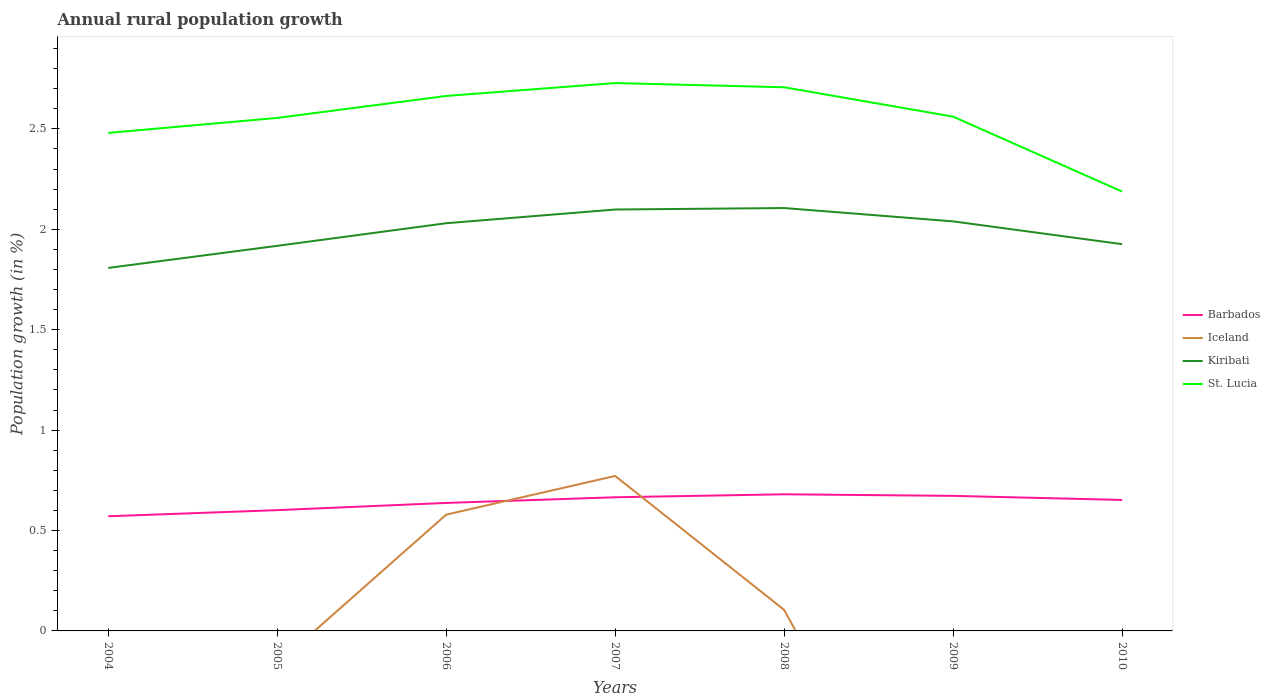How many different coloured lines are there?
Keep it short and to the point. 4. Is the number of lines equal to the number of legend labels?
Make the answer very short. No. Across all years, what is the maximum percentage of rural population growth in St. Lucia?
Provide a short and direct response. 2.19. What is the total percentage of rural population growth in St. Lucia in the graph?
Provide a succinct answer. -0.08. What is the difference between the highest and the second highest percentage of rural population growth in Barbados?
Give a very brief answer. 0.11. Does the graph contain any zero values?
Give a very brief answer. Yes. How are the legend labels stacked?
Your response must be concise. Vertical. What is the title of the graph?
Provide a short and direct response. Annual rural population growth. What is the label or title of the Y-axis?
Offer a very short reply. Population growth (in %). What is the Population growth (in %) in Barbados in 2004?
Make the answer very short. 0.57. What is the Population growth (in %) of Iceland in 2004?
Offer a very short reply. 0. What is the Population growth (in %) in Kiribati in 2004?
Give a very brief answer. 1.81. What is the Population growth (in %) of St. Lucia in 2004?
Your answer should be compact. 2.48. What is the Population growth (in %) of Barbados in 2005?
Make the answer very short. 0.6. What is the Population growth (in %) in Kiribati in 2005?
Your answer should be very brief. 1.92. What is the Population growth (in %) of St. Lucia in 2005?
Offer a terse response. 2.55. What is the Population growth (in %) of Barbados in 2006?
Provide a short and direct response. 0.64. What is the Population growth (in %) in Iceland in 2006?
Your answer should be very brief. 0.58. What is the Population growth (in %) of Kiribati in 2006?
Your response must be concise. 2.03. What is the Population growth (in %) of St. Lucia in 2006?
Your response must be concise. 2.66. What is the Population growth (in %) in Barbados in 2007?
Ensure brevity in your answer.  0.67. What is the Population growth (in %) in Iceland in 2007?
Offer a very short reply. 0.77. What is the Population growth (in %) of Kiribati in 2007?
Offer a terse response. 2.1. What is the Population growth (in %) of St. Lucia in 2007?
Make the answer very short. 2.73. What is the Population growth (in %) of Barbados in 2008?
Ensure brevity in your answer.  0.68. What is the Population growth (in %) in Iceland in 2008?
Your answer should be compact. 0.1. What is the Population growth (in %) in Kiribati in 2008?
Your response must be concise. 2.11. What is the Population growth (in %) of St. Lucia in 2008?
Your answer should be very brief. 2.71. What is the Population growth (in %) in Barbados in 2009?
Make the answer very short. 0.67. What is the Population growth (in %) of Kiribati in 2009?
Your response must be concise. 2.04. What is the Population growth (in %) in St. Lucia in 2009?
Make the answer very short. 2.56. What is the Population growth (in %) in Barbados in 2010?
Give a very brief answer. 0.65. What is the Population growth (in %) in Kiribati in 2010?
Make the answer very short. 1.93. What is the Population growth (in %) in St. Lucia in 2010?
Keep it short and to the point. 2.19. Across all years, what is the maximum Population growth (in %) of Barbados?
Your answer should be very brief. 0.68. Across all years, what is the maximum Population growth (in %) of Iceland?
Provide a succinct answer. 0.77. Across all years, what is the maximum Population growth (in %) in Kiribati?
Your answer should be compact. 2.11. Across all years, what is the maximum Population growth (in %) of St. Lucia?
Make the answer very short. 2.73. Across all years, what is the minimum Population growth (in %) of Barbados?
Your response must be concise. 0.57. Across all years, what is the minimum Population growth (in %) of Kiribati?
Provide a succinct answer. 1.81. Across all years, what is the minimum Population growth (in %) of St. Lucia?
Your answer should be very brief. 2.19. What is the total Population growth (in %) in Barbados in the graph?
Provide a short and direct response. 4.48. What is the total Population growth (in %) of Iceland in the graph?
Keep it short and to the point. 1.46. What is the total Population growth (in %) of Kiribati in the graph?
Provide a succinct answer. 13.93. What is the total Population growth (in %) in St. Lucia in the graph?
Offer a terse response. 17.88. What is the difference between the Population growth (in %) in Barbados in 2004 and that in 2005?
Provide a succinct answer. -0.03. What is the difference between the Population growth (in %) of Kiribati in 2004 and that in 2005?
Offer a terse response. -0.11. What is the difference between the Population growth (in %) of St. Lucia in 2004 and that in 2005?
Provide a short and direct response. -0.07. What is the difference between the Population growth (in %) of Barbados in 2004 and that in 2006?
Offer a very short reply. -0.07. What is the difference between the Population growth (in %) in Kiribati in 2004 and that in 2006?
Offer a very short reply. -0.22. What is the difference between the Population growth (in %) in St. Lucia in 2004 and that in 2006?
Keep it short and to the point. -0.18. What is the difference between the Population growth (in %) of Barbados in 2004 and that in 2007?
Your response must be concise. -0.09. What is the difference between the Population growth (in %) in Kiribati in 2004 and that in 2007?
Make the answer very short. -0.29. What is the difference between the Population growth (in %) of St. Lucia in 2004 and that in 2007?
Ensure brevity in your answer.  -0.25. What is the difference between the Population growth (in %) of Barbados in 2004 and that in 2008?
Keep it short and to the point. -0.11. What is the difference between the Population growth (in %) in Kiribati in 2004 and that in 2008?
Give a very brief answer. -0.3. What is the difference between the Population growth (in %) of St. Lucia in 2004 and that in 2008?
Offer a terse response. -0.23. What is the difference between the Population growth (in %) in Barbados in 2004 and that in 2009?
Keep it short and to the point. -0.1. What is the difference between the Population growth (in %) in Kiribati in 2004 and that in 2009?
Your response must be concise. -0.23. What is the difference between the Population growth (in %) in St. Lucia in 2004 and that in 2009?
Offer a very short reply. -0.08. What is the difference between the Population growth (in %) of Barbados in 2004 and that in 2010?
Provide a short and direct response. -0.08. What is the difference between the Population growth (in %) in Kiribati in 2004 and that in 2010?
Your answer should be very brief. -0.12. What is the difference between the Population growth (in %) of St. Lucia in 2004 and that in 2010?
Make the answer very short. 0.29. What is the difference between the Population growth (in %) in Barbados in 2005 and that in 2006?
Provide a succinct answer. -0.04. What is the difference between the Population growth (in %) in Kiribati in 2005 and that in 2006?
Offer a terse response. -0.11. What is the difference between the Population growth (in %) in St. Lucia in 2005 and that in 2006?
Ensure brevity in your answer.  -0.11. What is the difference between the Population growth (in %) of Barbados in 2005 and that in 2007?
Give a very brief answer. -0.06. What is the difference between the Population growth (in %) in Kiribati in 2005 and that in 2007?
Make the answer very short. -0.18. What is the difference between the Population growth (in %) of St. Lucia in 2005 and that in 2007?
Your answer should be very brief. -0.17. What is the difference between the Population growth (in %) of Barbados in 2005 and that in 2008?
Keep it short and to the point. -0.08. What is the difference between the Population growth (in %) of Kiribati in 2005 and that in 2008?
Offer a terse response. -0.19. What is the difference between the Population growth (in %) in St. Lucia in 2005 and that in 2008?
Provide a short and direct response. -0.15. What is the difference between the Population growth (in %) in Barbados in 2005 and that in 2009?
Your answer should be compact. -0.07. What is the difference between the Population growth (in %) in Kiribati in 2005 and that in 2009?
Provide a succinct answer. -0.12. What is the difference between the Population growth (in %) of St. Lucia in 2005 and that in 2009?
Your response must be concise. -0.01. What is the difference between the Population growth (in %) in Barbados in 2005 and that in 2010?
Your answer should be very brief. -0.05. What is the difference between the Population growth (in %) in Kiribati in 2005 and that in 2010?
Your answer should be very brief. -0.01. What is the difference between the Population growth (in %) in St. Lucia in 2005 and that in 2010?
Offer a terse response. 0.37. What is the difference between the Population growth (in %) of Barbados in 2006 and that in 2007?
Your answer should be very brief. -0.03. What is the difference between the Population growth (in %) of Iceland in 2006 and that in 2007?
Offer a very short reply. -0.19. What is the difference between the Population growth (in %) in Kiribati in 2006 and that in 2007?
Provide a short and direct response. -0.07. What is the difference between the Population growth (in %) in St. Lucia in 2006 and that in 2007?
Provide a short and direct response. -0.06. What is the difference between the Population growth (in %) in Barbados in 2006 and that in 2008?
Your response must be concise. -0.04. What is the difference between the Population growth (in %) in Iceland in 2006 and that in 2008?
Offer a very short reply. 0.47. What is the difference between the Population growth (in %) of Kiribati in 2006 and that in 2008?
Your response must be concise. -0.08. What is the difference between the Population growth (in %) in St. Lucia in 2006 and that in 2008?
Your response must be concise. -0.04. What is the difference between the Population growth (in %) in Barbados in 2006 and that in 2009?
Provide a succinct answer. -0.04. What is the difference between the Population growth (in %) in Kiribati in 2006 and that in 2009?
Provide a succinct answer. -0.01. What is the difference between the Population growth (in %) of St. Lucia in 2006 and that in 2009?
Offer a terse response. 0.1. What is the difference between the Population growth (in %) in Barbados in 2006 and that in 2010?
Ensure brevity in your answer.  -0.01. What is the difference between the Population growth (in %) of Kiribati in 2006 and that in 2010?
Your response must be concise. 0.1. What is the difference between the Population growth (in %) in St. Lucia in 2006 and that in 2010?
Make the answer very short. 0.48. What is the difference between the Population growth (in %) in Barbados in 2007 and that in 2008?
Make the answer very short. -0.01. What is the difference between the Population growth (in %) of Kiribati in 2007 and that in 2008?
Offer a very short reply. -0.01. What is the difference between the Population growth (in %) in St. Lucia in 2007 and that in 2008?
Offer a very short reply. 0.02. What is the difference between the Population growth (in %) of Barbados in 2007 and that in 2009?
Offer a terse response. -0.01. What is the difference between the Population growth (in %) of Kiribati in 2007 and that in 2009?
Your answer should be compact. 0.06. What is the difference between the Population growth (in %) in St. Lucia in 2007 and that in 2009?
Make the answer very short. 0.17. What is the difference between the Population growth (in %) of Barbados in 2007 and that in 2010?
Provide a succinct answer. 0.01. What is the difference between the Population growth (in %) of Kiribati in 2007 and that in 2010?
Your answer should be compact. 0.17. What is the difference between the Population growth (in %) in St. Lucia in 2007 and that in 2010?
Provide a succinct answer. 0.54. What is the difference between the Population growth (in %) of Barbados in 2008 and that in 2009?
Your answer should be compact. 0.01. What is the difference between the Population growth (in %) of Kiribati in 2008 and that in 2009?
Your answer should be very brief. 0.07. What is the difference between the Population growth (in %) of St. Lucia in 2008 and that in 2009?
Give a very brief answer. 0.15. What is the difference between the Population growth (in %) of Barbados in 2008 and that in 2010?
Offer a very short reply. 0.03. What is the difference between the Population growth (in %) in Kiribati in 2008 and that in 2010?
Offer a terse response. 0.18. What is the difference between the Population growth (in %) of St. Lucia in 2008 and that in 2010?
Your response must be concise. 0.52. What is the difference between the Population growth (in %) of Barbados in 2009 and that in 2010?
Make the answer very short. 0.02. What is the difference between the Population growth (in %) of Kiribati in 2009 and that in 2010?
Ensure brevity in your answer.  0.11. What is the difference between the Population growth (in %) in St. Lucia in 2009 and that in 2010?
Your answer should be very brief. 0.37. What is the difference between the Population growth (in %) of Barbados in 2004 and the Population growth (in %) of Kiribati in 2005?
Your answer should be very brief. -1.35. What is the difference between the Population growth (in %) of Barbados in 2004 and the Population growth (in %) of St. Lucia in 2005?
Your answer should be very brief. -1.98. What is the difference between the Population growth (in %) in Kiribati in 2004 and the Population growth (in %) in St. Lucia in 2005?
Give a very brief answer. -0.75. What is the difference between the Population growth (in %) of Barbados in 2004 and the Population growth (in %) of Iceland in 2006?
Give a very brief answer. -0.01. What is the difference between the Population growth (in %) of Barbados in 2004 and the Population growth (in %) of Kiribati in 2006?
Your answer should be very brief. -1.46. What is the difference between the Population growth (in %) in Barbados in 2004 and the Population growth (in %) in St. Lucia in 2006?
Your answer should be compact. -2.09. What is the difference between the Population growth (in %) in Kiribati in 2004 and the Population growth (in %) in St. Lucia in 2006?
Make the answer very short. -0.86. What is the difference between the Population growth (in %) in Barbados in 2004 and the Population growth (in %) in Iceland in 2007?
Offer a very short reply. -0.2. What is the difference between the Population growth (in %) in Barbados in 2004 and the Population growth (in %) in Kiribati in 2007?
Offer a very short reply. -1.53. What is the difference between the Population growth (in %) in Barbados in 2004 and the Population growth (in %) in St. Lucia in 2007?
Give a very brief answer. -2.16. What is the difference between the Population growth (in %) in Kiribati in 2004 and the Population growth (in %) in St. Lucia in 2007?
Offer a very short reply. -0.92. What is the difference between the Population growth (in %) of Barbados in 2004 and the Population growth (in %) of Iceland in 2008?
Ensure brevity in your answer.  0.47. What is the difference between the Population growth (in %) in Barbados in 2004 and the Population growth (in %) in Kiribati in 2008?
Offer a terse response. -1.53. What is the difference between the Population growth (in %) of Barbados in 2004 and the Population growth (in %) of St. Lucia in 2008?
Keep it short and to the point. -2.14. What is the difference between the Population growth (in %) of Kiribati in 2004 and the Population growth (in %) of St. Lucia in 2008?
Offer a very short reply. -0.9. What is the difference between the Population growth (in %) in Barbados in 2004 and the Population growth (in %) in Kiribati in 2009?
Your answer should be compact. -1.47. What is the difference between the Population growth (in %) in Barbados in 2004 and the Population growth (in %) in St. Lucia in 2009?
Offer a very short reply. -1.99. What is the difference between the Population growth (in %) of Kiribati in 2004 and the Population growth (in %) of St. Lucia in 2009?
Provide a succinct answer. -0.75. What is the difference between the Population growth (in %) in Barbados in 2004 and the Population growth (in %) in Kiribati in 2010?
Make the answer very short. -1.35. What is the difference between the Population growth (in %) of Barbados in 2004 and the Population growth (in %) of St. Lucia in 2010?
Provide a succinct answer. -1.62. What is the difference between the Population growth (in %) in Kiribati in 2004 and the Population growth (in %) in St. Lucia in 2010?
Provide a succinct answer. -0.38. What is the difference between the Population growth (in %) of Barbados in 2005 and the Population growth (in %) of Iceland in 2006?
Make the answer very short. 0.02. What is the difference between the Population growth (in %) of Barbados in 2005 and the Population growth (in %) of Kiribati in 2006?
Provide a succinct answer. -1.43. What is the difference between the Population growth (in %) of Barbados in 2005 and the Population growth (in %) of St. Lucia in 2006?
Give a very brief answer. -2.06. What is the difference between the Population growth (in %) of Kiribati in 2005 and the Population growth (in %) of St. Lucia in 2006?
Offer a terse response. -0.75. What is the difference between the Population growth (in %) of Barbados in 2005 and the Population growth (in %) of Iceland in 2007?
Provide a succinct answer. -0.17. What is the difference between the Population growth (in %) of Barbados in 2005 and the Population growth (in %) of Kiribati in 2007?
Offer a very short reply. -1.5. What is the difference between the Population growth (in %) in Barbados in 2005 and the Population growth (in %) in St. Lucia in 2007?
Ensure brevity in your answer.  -2.13. What is the difference between the Population growth (in %) of Kiribati in 2005 and the Population growth (in %) of St. Lucia in 2007?
Offer a very short reply. -0.81. What is the difference between the Population growth (in %) of Barbados in 2005 and the Population growth (in %) of Iceland in 2008?
Make the answer very short. 0.5. What is the difference between the Population growth (in %) of Barbados in 2005 and the Population growth (in %) of Kiribati in 2008?
Offer a very short reply. -1.5. What is the difference between the Population growth (in %) in Barbados in 2005 and the Population growth (in %) in St. Lucia in 2008?
Make the answer very short. -2.11. What is the difference between the Population growth (in %) in Kiribati in 2005 and the Population growth (in %) in St. Lucia in 2008?
Offer a terse response. -0.79. What is the difference between the Population growth (in %) of Barbados in 2005 and the Population growth (in %) of Kiribati in 2009?
Offer a terse response. -1.44. What is the difference between the Population growth (in %) of Barbados in 2005 and the Population growth (in %) of St. Lucia in 2009?
Provide a succinct answer. -1.96. What is the difference between the Population growth (in %) of Kiribati in 2005 and the Population growth (in %) of St. Lucia in 2009?
Your answer should be compact. -0.64. What is the difference between the Population growth (in %) of Barbados in 2005 and the Population growth (in %) of Kiribati in 2010?
Your answer should be compact. -1.32. What is the difference between the Population growth (in %) in Barbados in 2005 and the Population growth (in %) in St. Lucia in 2010?
Offer a terse response. -1.59. What is the difference between the Population growth (in %) in Kiribati in 2005 and the Population growth (in %) in St. Lucia in 2010?
Your answer should be very brief. -0.27. What is the difference between the Population growth (in %) in Barbados in 2006 and the Population growth (in %) in Iceland in 2007?
Provide a succinct answer. -0.13. What is the difference between the Population growth (in %) of Barbados in 2006 and the Population growth (in %) of Kiribati in 2007?
Provide a succinct answer. -1.46. What is the difference between the Population growth (in %) of Barbados in 2006 and the Population growth (in %) of St. Lucia in 2007?
Keep it short and to the point. -2.09. What is the difference between the Population growth (in %) of Iceland in 2006 and the Population growth (in %) of Kiribati in 2007?
Keep it short and to the point. -1.52. What is the difference between the Population growth (in %) of Iceland in 2006 and the Population growth (in %) of St. Lucia in 2007?
Keep it short and to the point. -2.15. What is the difference between the Population growth (in %) of Kiribati in 2006 and the Population growth (in %) of St. Lucia in 2007?
Your answer should be compact. -0.7. What is the difference between the Population growth (in %) of Barbados in 2006 and the Population growth (in %) of Iceland in 2008?
Ensure brevity in your answer.  0.53. What is the difference between the Population growth (in %) of Barbados in 2006 and the Population growth (in %) of Kiribati in 2008?
Give a very brief answer. -1.47. What is the difference between the Population growth (in %) in Barbados in 2006 and the Population growth (in %) in St. Lucia in 2008?
Your answer should be compact. -2.07. What is the difference between the Population growth (in %) in Iceland in 2006 and the Population growth (in %) in Kiribati in 2008?
Keep it short and to the point. -1.53. What is the difference between the Population growth (in %) in Iceland in 2006 and the Population growth (in %) in St. Lucia in 2008?
Provide a succinct answer. -2.13. What is the difference between the Population growth (in %) of Kiribati in 2006 and the Population growth (in %) of St. Lucia in 2008?
Keep it short and to the point. -0.68. What is the difference between the Population growth (in %) of Barbados in 2006 and the Population growth (in %) of Kiribati in 2009?
Ensure brevity in your answer.  -1.4. What is the difference between the Population growth (in %) in Barbados in 2006 and the Population growth (in %) in St. Lucia in 2009?
Offer a very short reply. -1.92. What is the difference between the Population growth (in %) of Iceland in 2006 and the Population growth (in %) of Kiribati in 2009?
Provide a succinct answer. -1.46. What is the difference between the Population growth (in %) in Iceland in 2006 and the Population growth (in %) in St. Lucia in 2009?
Offer a very short reply. -1.98. What is the difference between the Population growth (in %) in Kiribati in 2006 and the Population growth (in %) in St. Lucia in 2009?
Your response must be concise. -0.53. What is the difference between the Population growth (in %) in Barbados in 2006 and the Population growth (in %) in Kiribati in 2010?
Keep it short and to the point. -1.29. What is the difference between the Population growth (in %) in Barbados in 2006 and the Population growth (in %) in St. Lucia in 2010?
Offer a very short reply. -1.55. What is the difference between the Population growth (in %) in Iceland in 2006 and the Population growth (in %) in Kiribati in 2010?
Your response must be concise. -1.35. What is the difference between the Population growth (in %) in Iceland in 2006 and the Population growth (in %) in St. Lucia in 2010?
Provide a succinct answer. -1.61. What is the difference between the Population growth (in %) in Kiribati in 2006 and the Population growth (in %) in St. Lucia in 2010?
Provide a succinct answer. -0.16. What is the difference between the Population growth (in %) in Barbados in 2007 and the Population growth (in %) in Iceland in 2008?
Your answer should be compact. 0.56. What is the difference between the Population growth (in %) in Barbados in 2007 and the Population growth (in %) in Kiribati in 2008?
Make the answer very short. -1.44. What is the difference between the Population growth (in %) of Barbados in 2007 and the Population growth (in %) of St. Lucia in 2008?
Your answer should be compact. -2.04. What is the difference between the Population growth (in %) in Iceland in 2007 and the Population growth (in %) in Kiribati in 2008?
Keep it short and to the point. -1.33. What is the difference between the Population growth (in %) in Iceland in 2007 and the Population growth (in %) in St. Lucia in 2008?
Your response must be concise. -1.94. What is the difference between the Population growth (in %) of Kiribati in 2007 and the Population growth (in %) of St. Lucia in 2008?
Provide a succinct answer. -0.61. What is the difference between the Population growth (in %) of Barbados in 2007 and the Population growth (in %) of Kiribati in 2009?
Your answer should be very brief. -1.37. What is the difference between the Population growth (in %) in Barbados in 2007 and the Population growth (in %) in St. Lucia in 2009?
Your response must be concise. -1.9. What is the difference between the Population growth (in %) of Iceland in 2007 and the Population growth (in %) of Kiribati in 2009?
Give a very brief answer. -1.27. What is the difference between the Population growth (in %) of Iceland in 2007 and the Population growth (in %) of St. Lucia in 2009?
Ensure brevity in your answer.  -1.79. What is the difference between the Population growth (in %) of Kiribati in 2007 and the Population growth (in %) of St. Lucia in 2009?
Keep it short and to the point. -0.46. What is the difference between the Population growth (in %) in Barbados in 2007 and the Population growth (in %) in Kiribati in 2010?
Offer a terse response. -1.26. What is the difference between the Population growth (in %) of Barbados in 2007 and the Population growth (in %) of St. Lucia in 2010?
Ensure brevity in your answer.  -1.52. What is the difference between the Population growth (in %) in Iceland in 2007 and the Population growth (in %) in Kiribati in 2010?
Offer a very short reply. -1.15. What is the difference between the Population growth (in %) in Iceland in 2007 and the Population growth (in %) in St. Lucia in 2010?
Ensure brevity in your answer.  -1.42. What is the difference between the Population growth (in %) of Kiribati in 2007 and the Population growth (in %) of St. Lucia in 2010?
Offer a very short reply. -0.09. What is the difference between the Population growth (in %) in Barbados in 2008 and the Population growth (in %) in Kiribati in 2009?
Ensure brevity in your answer.  -1.36. What is the difference between the Population growth (in %) of Barbados in 2008 and the Population growth (in %) of St. Lucia in 2009?
Your response must be concise. -1.88. What is the difference between the Population growth (in %) in Iceland in 2008 and the Population growth (in %) in Kiribati in 2009?
Offer a very short reply. -1.93. What is the difference between the Population growth (in %) in Iceland in 2008 and the Population growth (in %) in St. Lucia in 2009?
Offer a very short reply. -2.46. What is the difference between the Population growth (in %) in Kiribati in 2008 and the Population growth (in %) in St. Lucia in 2009?
Offer a very short reply. -0.46. What is the difference between the Population growth (in %) of Barbados in 2008 and the Population growth (in %) of Kiribati in 2010?
Your answer should be very brief. -1.25. What is the difference between the Population growth (in %) in Barbados in 2008 and the Population growth (in %) in St. Lucia in 2010?
Give a very brief answer. -1.51. What is the difference between the Population growth (in %) of Iceland in 2008 and the Population growth (in %) of Kiribati in 2010?
Provide a succinct answer. -1.82. What is the difference between the Population growth (in %) of Iceland in 2008 and the Population growth (in %) of St. Lucia in 2010?
Give a very brief answer. -2.08. What is the difference between the Population growth (in %) in Kiribati in 2008 and the Population growth (in %) in St. Lucia in 2010?
Keep it short and to the point. -0.08. What is the difference between the Population growth (in %) in Barbados in 2009 and the Population growth (in %) in Kiribati in 2010?
Provide a short and direct response. -1.25. What is the difference between the Population growth (in %) in Barbados in 2009 and the Population growth (in %) in St. Lucia in 2010?
Provide a succinct answer. -1.52. What is the difference between the Population growth (in %) of Kiribati in 2009 and the Population growth (in %) of St. Lucia in 2010?
Give a very brief answer. -0.15. What is the average Population growth (in %) of Barbados per year?
Give a very brief answer. 0.64. What is the average Population growth (in %) in Iceland per year?
Provide a succinct answer. 0.21. What is the average Population growth (in %) of Kiribati per year?
Your answer should be very brief. 1.99. What is the average Population growth (in %) of St. Lucia per year?
Provide a short and direct response. 2.55. In the year 2004, what is the difference between the Population growth (in %) in Barbados and Population growth (in %) in Kiribati?
Provide a succinct answer. -1.24. In the year 2004, what is the difference between the Population growth (in %) in Barbados and Population growth (in %) in St. Lucia?
Your answer should be very brief. -1.91. In the year 2004, what is the difference between the Population growth (in %) in Kiribati and Population growth (in %) in St. Lucia?
Provide a succinct answer. -0.67. In the year 2005, what is the difference between the Population growth (in %) of Barbados and Population growth (in %) of Kiribati?
Make the answer very short. -1.32. In the year 2005, what is the difference between the Population growth (in %) in Barbados and Population growth (in %) in St. Lucia?
Offer a very short reply. -1.95. In the year 2005, what is the difference between the Population growth (in %) of Kiribati and Population growth (in %) of St. Lucia?
Provide a succinct answer. -0.64. In the year 2006, what is the difference between the Population growth (in %) of Barbados and Population growth (in %) of Iceland?
Offer a very short reply. 0.06. In the year 2006, what is the difference between the Population growth (in %) of Barbados and Population growth (in %) of Kiribati?
Provide a short and direct response. -1.39. In the year 2006, what is the difference between the Population growth (in %) in Barbados and Population growth (in %) in St. Lucia?
Make the answer very short. -2.03. In the year 2006, what is the difference between the Population growth (in %) of Iceland and Population growth (in %) of Kiribati?
Keep it short and to the point. -1.45. In the year 2006, what is the difference between the Population growth (in %) of Iceland and Population growth (in %) of St. Lucia?
Your answer should be compact. -2.09. In the year 2006, what is the difference between the Population growth (in %) of Kiribati and Population growth (in %) of St. Lucia?
Offer a terse response. -0.63. In the year 2007, what is the difference between the Population growth (in %) of Barbados and Population growth (in %) of Iceland?
Make the answer very short. -0.11. In the year 2007, what is the difference between the Population growth (in %) of Barbados and Population growth (in %) of Kiribati?
Your response must be concise. -1.43. In the year 2007, what is the difference between the Population growth (in %) of Barbados and Population growth (in %) of St. Lucia?
Provide a short and direct response. -2.06. In the year 2007, what is the difference between the Population growth (in %) of Iceland and Population growth (in %) of Kiribati?
Offer a very short reply. -1.33. In the year 2007, what is the difference between the Population growth (in %) in Iceland and Population growth (in %) in St. Lucia?
Offer a terse response. -1.96. In the year 2007, what is the difference between the Population growth (in %) in Kiribati and Population growth (in %) in St. Lucia?
Provide a succinct answer. -0.63. In the year 2008, what is the difference between the Population growth (in %) in Barbados and Population growth (in %) in Iceland?
Keep it short and to the point. 0.58. In the year 2008, what is the difference between the Population growth (in %) in Barbados and Population growth (in %) in Kiribati?
Provide a succinct answer. -1.43. In the year 2008, what is the difference between the Population growth (in %) of Barbados and Population growth (in %) of St. Lucia?
Give a very brief answer. -2.03. In the year 2008, what is the difference between the Population growth (in %) of Iceland and Population growth (in %) of Kiribati?
Your response must be concise. -2. In the year 2008, what is the difference between the Population growth (in %) in Iceland and Population growth (in %) in St. Lucia?
Your response must be concise. -2.6. In the year 2008, what is the difference between the Population growth (in %) in Kiribati and Population growth (in %) in St. Lucia?
Provide a short and direct response. -0.6. In the year 2009, what is the difference between the Population growth (in %) of Barbados and Population growth (in %) of Kiribati?
Provide a short and direct response. -1.37. In the year 2009, what is the difference between the Population growth (in %) in Barbados and Population growth (in %) in St. Lucia?
Your response must be concise. -1.89. In the year 2009, what is the difference between the Population growth (in %) in Kiribati and Population growth (in %) in St. Lucia?
Your response must be concise. -0.52. In the year 2010, what is the difference between the Population growth (in %) in Barbados and Population growth (in %) in Kiribati?
Your response must be concise. -1.27. In the year 2010, what is the difference between the Population growth (in %) in Barbados and Population growth (in %) in St. Lucia?
Offer a very short reply. -1.54. In the year 2010, what is the difference between the Population growth (in %) in Kiribati and Population growth (in %) in St. Lucia?
Keep it short and to the point. -0.26. What is the ratio of the Population growth (in %) of Barbados in 2004 to that in 2005?
Provide a short and direct response. 0.95. What is the ratio of the Population growth (in %) in Kiribati in 2004 to that in 2005?
Ensure brevity in your answer.  0.94. What is the ratio of the Population growth (in %) in St. Lucia in 2004 to that in 2005?
Ensure brevity in your answer.  0.97. What is the ratio of the Population growth (in %) of Barbados in 2004 to that in 2006?
Offer a very short reply. 0.9. What is the ratio of the Population growth (in %) of Kiribati in 2004 to that in 2006?
Provide a succinct answer. 0.89. What is the ratio of the Population growth (in %) in St. Lucia in 2004 to that in 2006?
Provide a short and direct response. 0.93. What is the ratio of the Population growth (in %) in Barbados in 2004 to that in 2007?
Provide a short and direct response. 0.86. What is the ratio of the Population growth (in %) of Kiribati in 2004 to that in 2007?
Give a very brief answer. 0.86. What is the ratio of the Population growth (in %) of St. Lucia in 2004 to that in 2007?
Make the answer very short. 0.91. What is the ratio of the Population growth (in %) in Barbados in 2004 to that in 2008?
Offer a very short reply. 0.84. What is the ratio of the Population growth (in %) of Kiribati in 2004 to that in 2008?
Provide a short and direct response. 0.86. What is the ratio of the Population growth (in %) in St. Lucia in 2004 to that in 2008?
Ensure brevity in your answer.  0.92. What is the ratio of the Population growth (in %) in Barbados in 2004 to that in 2009?
Your answer should be compact. 0.85. What is the ratio of the Population growth (in %) in Kiribati in 2004 to that in 2009?
Your answer should be compact. 0.89. What is the ratio of the Population growth (in %) of St. Lucia in 2004 to that in 2009?
Give a very brief answer. 0.97. What is the ratio of the Population growth (in %) in Barbados in 2004 to that in 2010?
Make the answer very short. 0.88. What is the ratio of the Population growth (in %) in Kiribati in 2004 to that in 2010?
Provide a succinct answer. 0.94. What is the ratio of the Population growth (in %) of St. Lucia in 2004 to that in 2010?
Ensure brevity in your answer.  1.13. What is the ratio of the Population growth (in %) in Barbados in 2005 to that in 2006?
Your answer should be compact. 0.94. What is the ratio of the Population growth (in %) in Kiribati in 2005 to that in 2006?
Provide a succinct answer. 0.94. What is the ratio of the Population growth (in %) in St. Lucia in 2005 to that in 2006?
Your answer should be very brief. 0.96. What is the ratio of the Population growth (in %) in Barbados in 2005 to that in 2007?
Offer a terse response. 0.9. What is the ratio of the Population growth (in %) in Kiribati in 2005 to that in 2007?
Your answer should be very brief. 0.91. What is the ratio of the Population growth (in %) of St. Lucia in 2005 to that in 2007?
Keep it short and to the point. 0.94. What is the ratio of the Population growth (in %) in Barbados in 2005 to that in 2008?
Your answer should be compact. 0.88. What is the ratio of the Population growth (in %) of Kiribati in 2005 to that in 2008?
Offer a very short reply. 0.91. What is the ratio of the Population growth (in %) of St. Lucia in 2005 to that in 2008?
Ensure brevity in your answer.  0.94. What is the ratio of the Population growth (in %) in Barbados in 2005 to that in 2009?
Ensure brevity in your answer.  0.89. What is the ratio of the Population growth (in %) of Kiribati in 2005 to that in 2009?
Ensure brevity in your answer.  0.94. What is the ratio of the Population growth (in %) in St. Lucia in 2005 to that in 2009?
Make the answer very short. 1. What is the ratio of the Population growth (in %) in Barbados in 2005 to that in 2010?
Offer a very short reply. 0.92. What is the ratio of the Population growth (in %) of Kiribati in 2005 to that in 2010?
Your answer should be compact. 1. What is the ratio of the Population growth (in %) of St. Lucia in 2005 to that in 2010?
Offer a very short reply. 1.17. What is the ratio of the Population growth (in %) in Barbados in 2006 to that in 2007?
Provide a succinct answer. 0.96. What is the ratio of the Population growth (in %) in Iceland in 2006 to that in 2007?
Your answer should be very brief. 0.75. What is the ratio of the Population growth (in %) in Kiribati in 2006 to that in 2007?
Provide a succinct answer. 0.97. What is the ratio of the Population growth (in %) of St. Lucia in 2006 to that in 2007?
Give a very brief answer. 0.98. What is the ratio of the Population growth (in %) of Barbados in 2006 to that in 2008?
Offer a very short reply. 0.94. What is the ratio of the Population growth (in %) in Iceland in 2006 to that in 2008?
Your response must be concise. 5.52. What is the ratio of the Population growth (in %) in Kiribati in 2006 to that in 2008?
Your answer should be compact. 0.96. What is the ratio of the Population growth (in %) of St. Lucia in 2006 to that in 2008?
Keep it short and to the point. 0.98. What is the ratio of the Population growth (in %) of Barbados in 2006 to that in 2009?
Your response must be concise. 0.95. What is the ratio of the Population growth (in %) in Kiribati in 2006 to that in 2009?
Make the answer very short. 1. What is the ratio of the Population growth (in %) of St. Lucia in 2006 to that in 2009?
Offer a very short reply. 1.04. What is the ratio of the Population growth (in %) of Barbados in 2006 to that in 2010?
Your answer should be very brief. 0.98. What is the ratio of the Population growth (in %) in Kiribati in 2006 to that in 2010?
Provide a short and direct response. 1.05. What is the ratio of the Population growth (in %) in St. Lucia in 2006 to that in 2010?
Ensure brevity in your answer.  1.22. What is the ratio of the Population growth (in %) of Barbados in 2007 to that in 2008?
Your answer should be very brief. 0.98. What is the ratio of the Population growth (in %) of Iceland in 2007 to that in 2008?
Provide a succinct answer. 7.35. What is the ratio of the Population growth (in %) of Barbados in 2007 to that in 2009?
Your answer should be very brief. 0.99. What is the ratio of the Population growth (in %) of St. Lucia in 2007 to that in 2009?
Provide a succinct answer. 1.07. What is the ratio of the Population growth (in %) of Barbados in 2007 to that in 2010?
Give a very brief answer. 1.02. What is the ratio of the Population growth (in %) of Kiribati in 2007 to that in 2010?
Your response must be concise. 1.09. What is the ratio of the Population growth (in %) of St. Lucia in 2007 to that in 2010?
Provide a short and direct response. 1.25. What is the ratio of the Population growth (in %) of Barbados in 2008 to that in 2009?
Keep it short and to the point. 1.01. What is the ratio of the Population growth (in %) of Kiribati in 2008 to that in 2009?
Offer a very short reply. 1.03. What is the ratio of the Population growth (in %) of St. Lucia in 2008 to that in 2009?
Your response must be concise. 1.06. What is the ratio of the Population growth (in %) of Barbados in 2008 to that in 2010?
Make the answer very short. 1.04. What is the ratio of the Population growth (in %) of Kiribati in 2008 to that in 2010?
Make the answer very short. 1.09. What is the ratio of the Population growth (in %) in St. Lucia in 2008 to that in 2010?
Your response must be concise. 1.24. What is the ratio of the Population growth (in %) in Barbados in 2009 to that in 2010?
Your answer should be very brief. 1.03. What is the ratio of the Population growth (in %) in Kiribati in 2009 to that in 2010?
Offer a very short reply. 1.06. What is the ratio of the Population growth (in %) in St. Lucia in 2009 to that in 2010?
Your answer should be compact. 1.17. What is the difference between the highest and the second highest Population growth (in %) in Barbados?
Keep it short and to the point. 0.01. What is the difference between the highest and the second highest Population growth (in %) of Iceland?
Keep it short and to the point. 0.19. What is the difference between the highest and the second highest Population growth (in %) in Kiribati?
Offer a terse response. 0.01. What is the difference between the highest and the second highest Population growth (in %) of St. Lucia?
Offer a terse response. 0.02. What is the difference between the highest and the lowest Population growth (in %) in Barbados?
Ensure brevity in your answer.  0.11. What is the difference between the highest and the lowest Population growth (in %) in Iceland?
Keep it short and to the point. 0.77. What is the difference between the highest and the lowest Population growth (in %) in Kiribati?
Your answer should be compact. 0.3. What is the difference between the highest and the lowest Population growth (in %) of St. Lucia?
Make the answer very short. 0.54. 